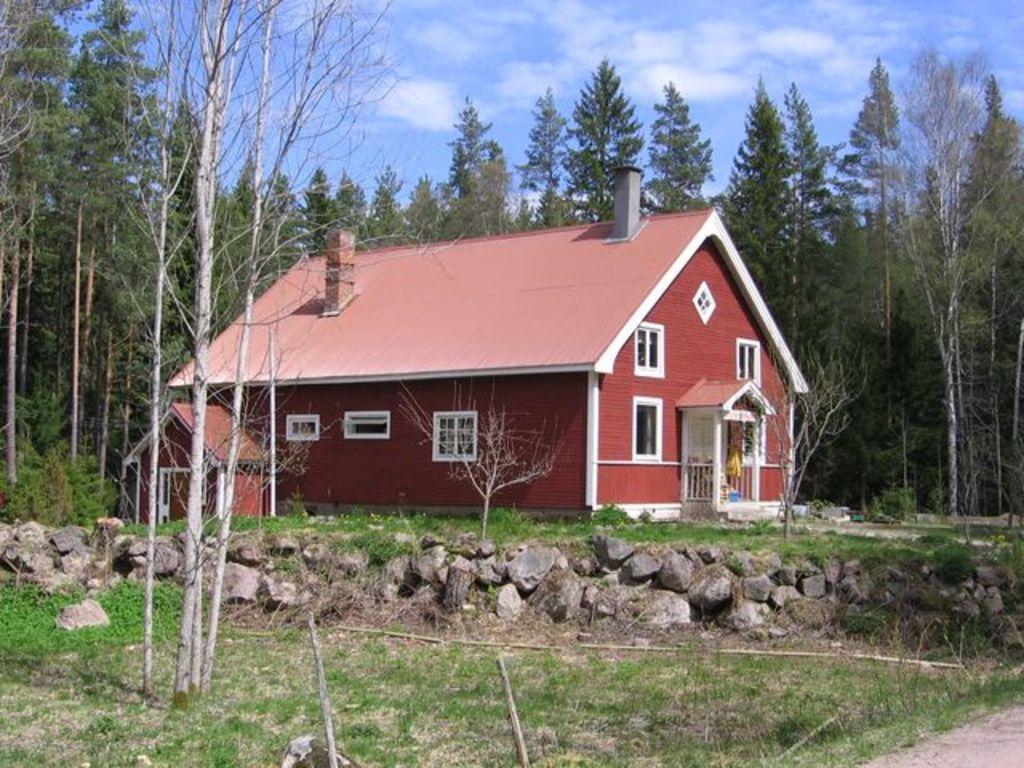How would you summarize this image in a sentence or two? This is an outside view. In the middle of the image there is a house. At the bottom, I can see the grass and there are some stones. In the background there are many trees. At the top of the image I can see the sky and clouds. 